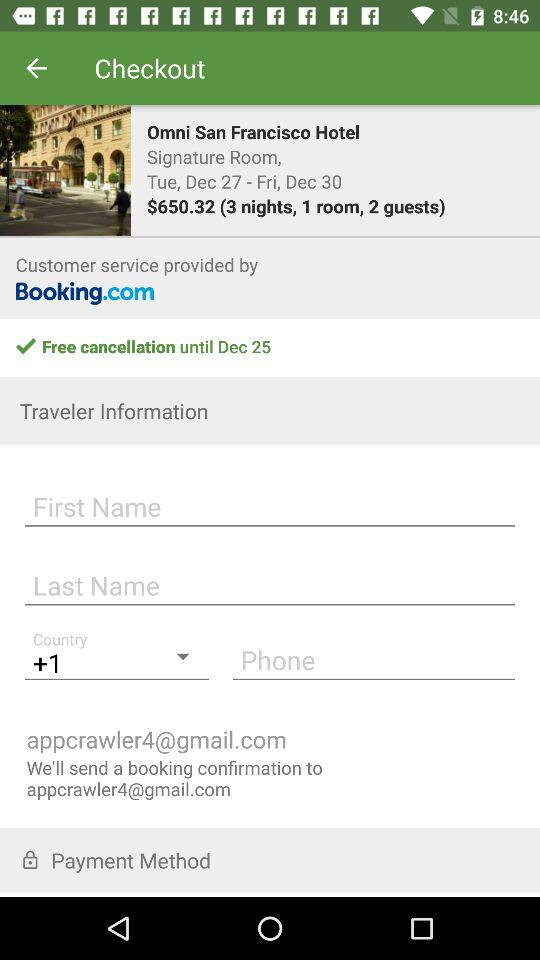What is the last date for free cancellation? The last date for free cancellation is December 25. 